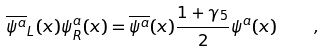<formula> <loc_0><loc_0><loc_500><loc_500>\overline { \psi ^ { a } } _ { L } ( x ) \psi ^ { a } _ { R } ( x ) = \overline { \psi ^ { a } } ( x ) \frac { 1 + \gamma _ { 5 } } { 2 } \psi ^ { a } ( x ) \quad ,</formula> 